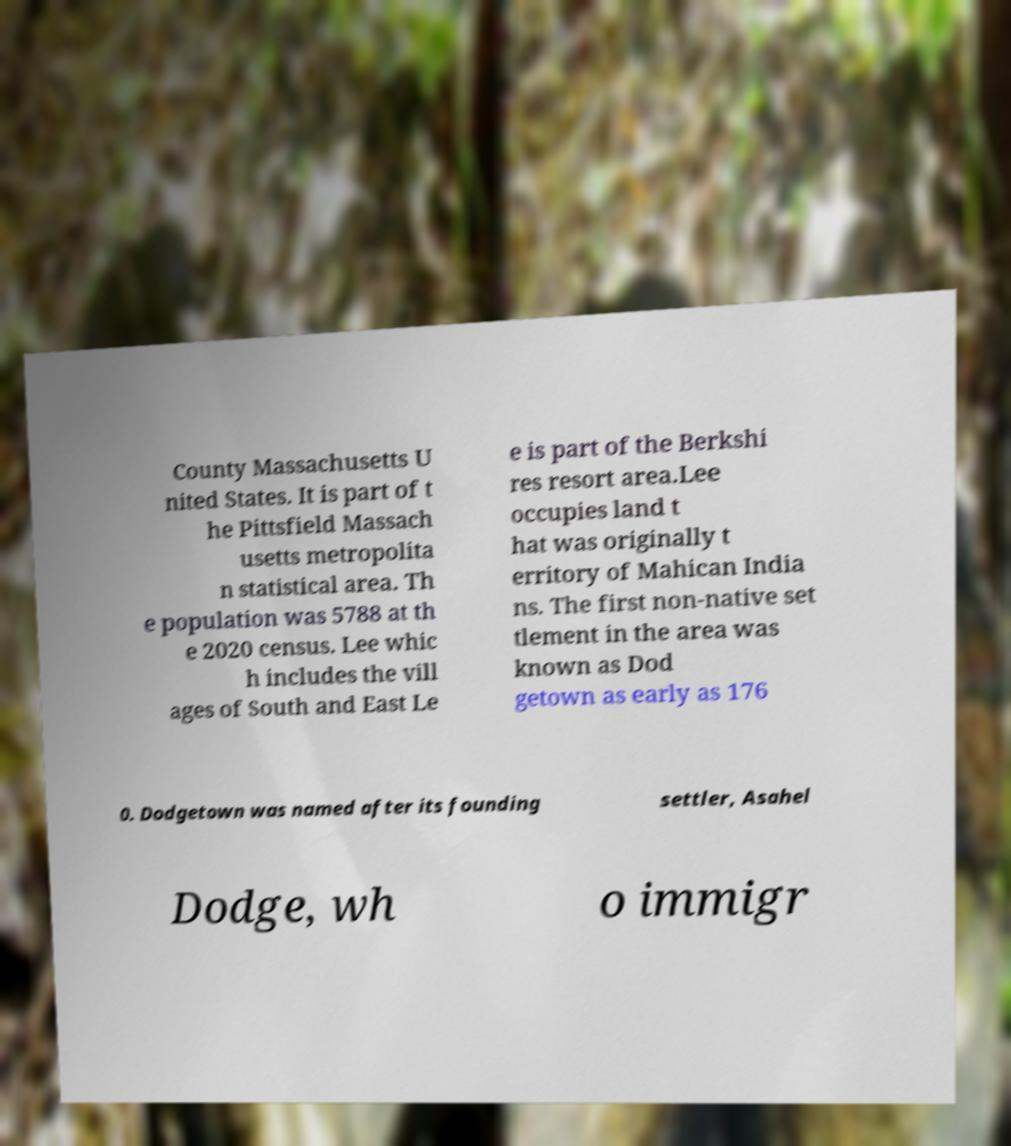Please identify and transcribe the text found in this image. County Massachusetts U nited States. It is part of t he Pittsfield Massach usetts metropolita n statistical area. Th e population was 5788 at th e 2020 census. Lee whic h includes the vill ages of South and East Le e is part of the Berkshi res resort area.Lee occupies land t hat was originally t erritory of Mahican India ns. The first non-native set tlement in the area was known as Dod getown as early as 176 0. Dodgetown was named after its founding settler, Asahel Dodge, wh o immigr 